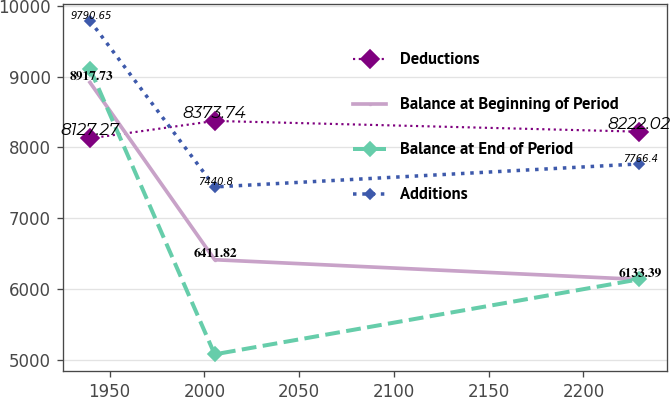<chart> <loc_0><loc_0><loc_500><loc_500><line_chart><ecel><fcel>Deductions<fcel>Balance at Beginning of Period<fcel>Balance at End of Period<fcel>Additions<nl><fcel>1939.66<fcel>8127.27<fcel>8917.73<fcel>9111.88<fcel>9790.65<nl><fcel>2005.44<fcel>8373.74<fcel>6411.82<fcel>5074.65<fcel>7440.8<nl><fcel>2229.45<fcel>8222.02<fcel>6133.39<fcel>6135.41<fcel>7766.4<nl></chart> 